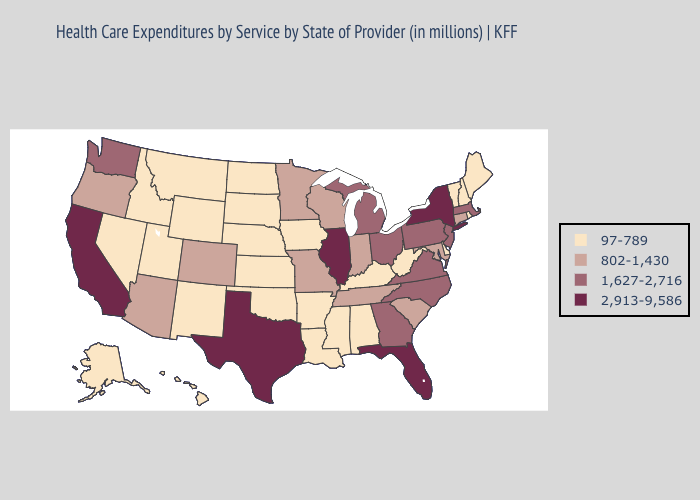How many symbols are there in the legend?
Keep it brief. 4. What is the lowest value in states that border Colorado?
Answer briefly. 97-789. Name the states that have a value in the range 1,627-2,716?
Keep it brief. Georgia, Massachusetts, Michigan, New Jersey, North Carolina, Ohio, Pennsylvania, Virginia, Washington. Does West Virginia have the highest value in the South?
Concise answer only. No. What is the value of Connecticut?
Concise answer only. 802-1,430. Does Massachusetts have the lowest value in the USA?
Concise answer only. No. Which states have the highest value in the USA?
Short answer required. California, Florida, Illinois, New York, Texas. What is the value of Missouri?
Be succinct. 802-1,430. Among the states that border Missouri , which have the highest value?
Quick response, please. Illinois. What is the value of Kansas?
Give a very brief answer. 97-789. Is the legend a continuous bar?
Write a very short answer. No. Which states have the lowest value in the USA?
Concise answer only. Alabama, Alaska, Arkansas, Delaware, Hawaii, Idaho, Iowa, Kansas, Kentucky, Louisiana, Maine, Mississippi, Montana, Nebraska, Nevada, New Hampshire, New Mexico, North Dakota, Oklahoma, Rhode Island, South Dakota, Utah, Vermont, West Virginia, Wyoming. What is the value of Michigan?
Answer briefly. 1,627-2,716. What is the value of Pennsylvania?
Give a very brief answer. 1,627-2,716. Name the states that have a value in the range 802-1,430?
Quick response, please. Arizona, Colorado, Connecticut, Indiana, Maryland, Minnesota, Missouri, Oregon, South Carolina, Tennessee, Wisconsin. 